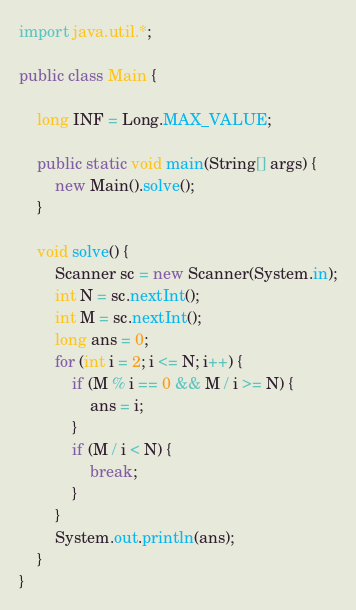<code> <loc_0><loc_0><loc_500><loc_500><_Java_>import java.util.*;

public class Main {

    long INF = Long.MAX_VALUE;

    public static void main(String[] args) {
        new Main().solve();
    }

    void solve() {
        Scanner sc = new Scanner(System.in);
        int N = sc.nextInt();
        int M = sc.nextInt();
        long ans = 0;
        for (int i = 2; i <= N; i++) {
            if (M % i == 0 && M / i >= N) {
                ans = i;
            }
            if (M / i < N) {
                break;
            }
        }
        System.out.println(ans);
    }
}</code> 